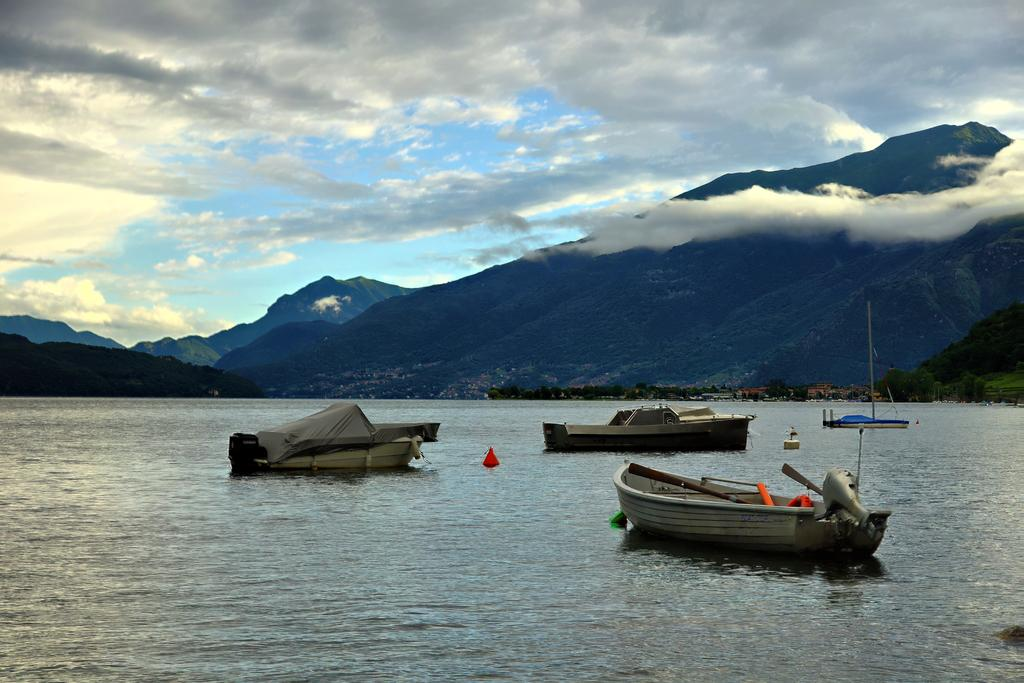What type of natural landform can be seen in the image? There are mountains in the image. What type of vegetation is present in the image? There are trees in the image. What type of watercraft can be seen in the image? There are boats on the water surface in the image. What colors are visible in the sky in the image? The sky is blue and white in color. What type of dress is the partner wearing at the party in the image? There is no dress, partner, or party present in the image. The image features mountains, trees, boats, and a blue and white sky. 